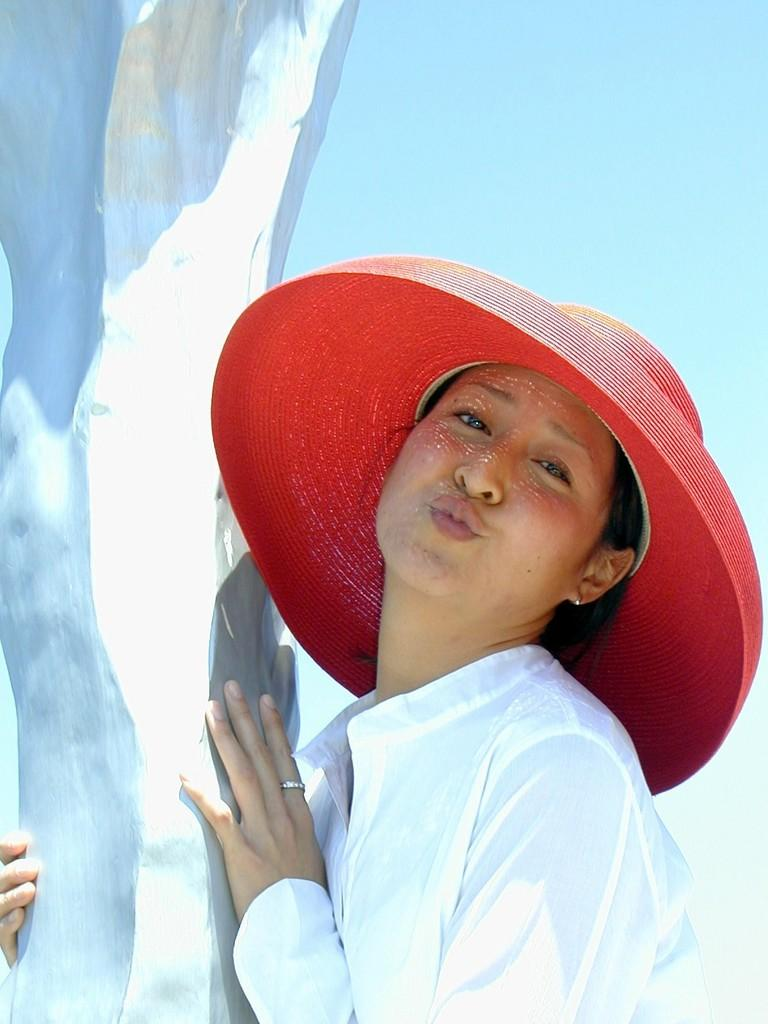Who is present in the image? There is a woman in the image. What is the woman wearing? The woman is wearing a white dress and a red hat. What can be seen in the background of the image? There is sky visible in the background of the image. How many brothers does the woman have in the image? There is no information about the woman's brothers in the image, so we cannot determine their number. Are there any dinosaurs visible in the image? No, there are no dinosaurs present in the image. 